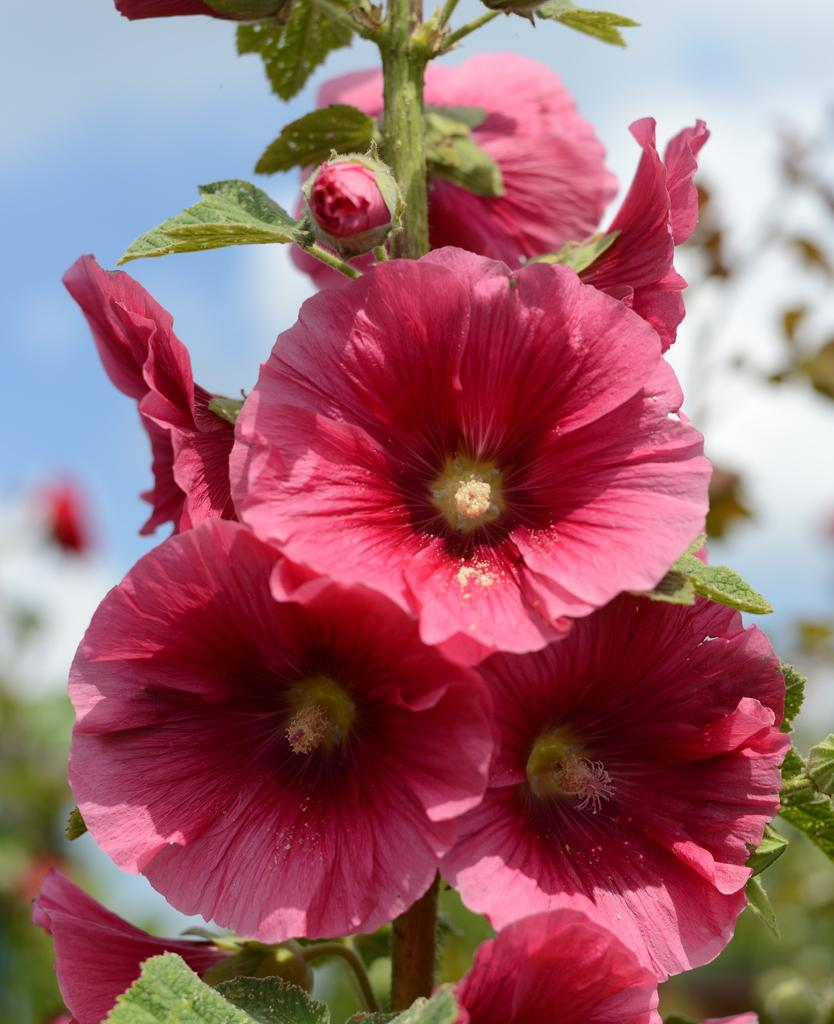What type of living organisms can be seen in the image? Flowers and plants can be seen in the image. Can you describe the flowers in the image? Unfortunately, the provided facts do not include specific details about the flowers. How many different types of plants are visible in the image? The provided facts do not specify the number of different types of plants visible in the image. What type of bun is being served on the plate in the image? There is no plate or bun present in the image; it features flowers and plants. What color is the orange in the image? There is no orange present in the image; it features flowers and plants. 